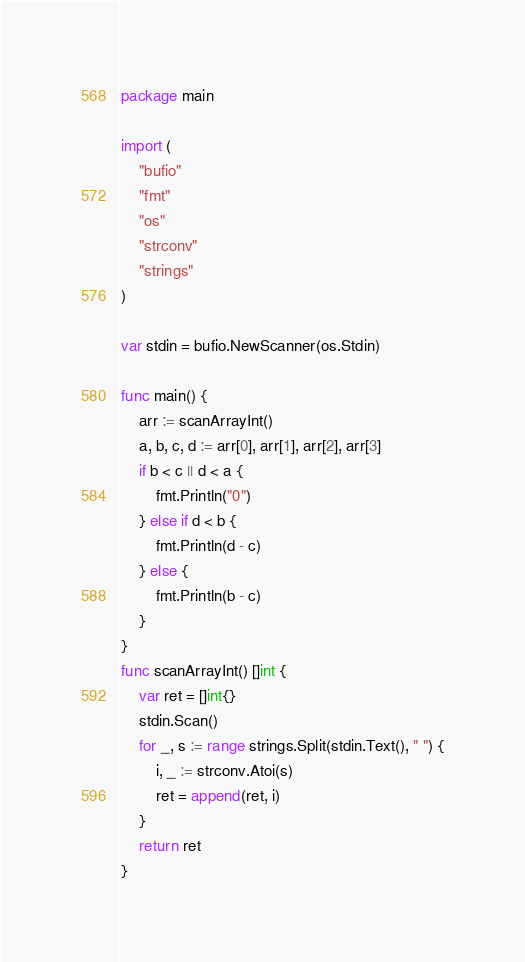<code> <loc_0><loc_0><loc_500><loc_500><_Go_>package main

import (
	"bufio"
	"fmt"
	"os"
	"strconv"
	"strings"
)

var stdin = bufio.NewScanner(os.Stdin)

func main() {
	arr := scanArrayInt()
	a, b, c, d := arr[0], arr[1], arr[2], arr[3]
	if b < c || d < a {
		fmt.Println("0")
	} else if d < b {
		fmt.Println(d - c)
	} else {
		fmt.Println(b - c)
	}
}
func scanArrayInt() []int {
	var ret = []int{}
	stdin.Scan()
	for _, s := range strings.Split(stdin.Text(), " ") {
		i, _ := strconv.Atoi(s)
		ret = append(ret, i)
	}
	return ret
}</code> 